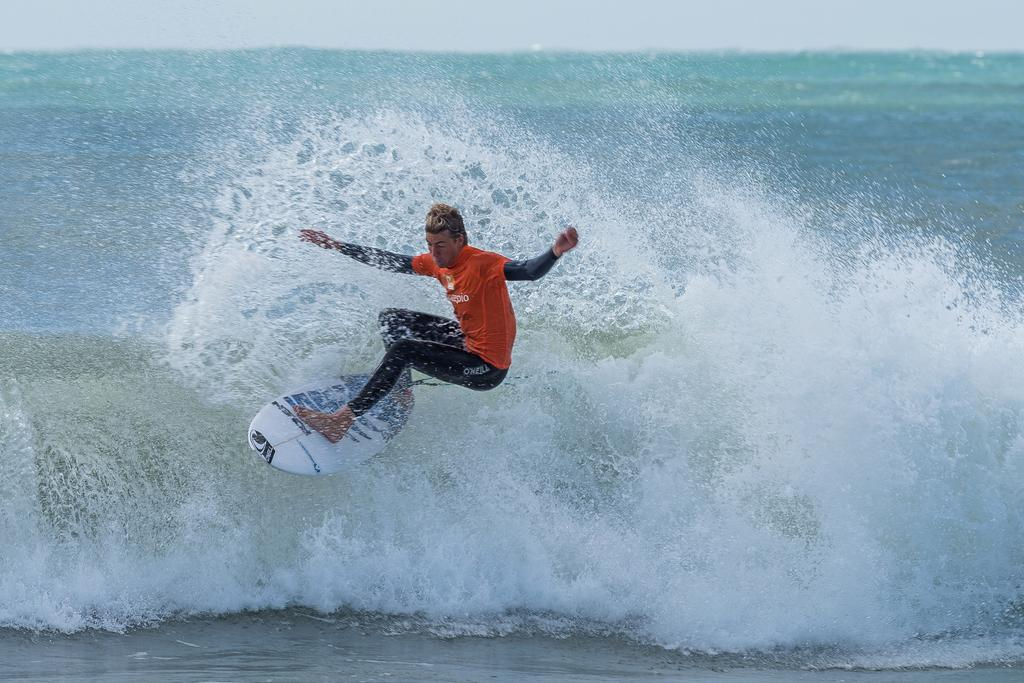<image>
Summarize the visual content of the image. Oneill reads the brand on the surfing gear. 